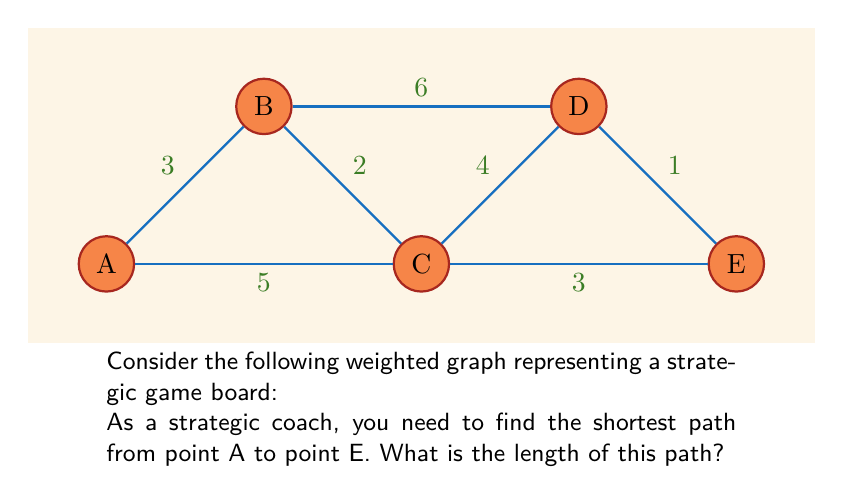Give your solution to this math problem. To solve this problem, we'll use Dijkstra's algorithm to find the shortest path from A to E. Let's go through the steps:

1) Initialize:
   - Distance to A: 0
   - Distance to all other nodes: $\infty$
   - Set of unvisited nodes: {A, B, C, D, E}

2) Start from node A:
   - Update distances:
     A to B: 3
     A to C: 5
   - Mark A as visited
   - Unvisited set: {B, C, D, E}

3) Choose the node with the smallest distance (B):
   - Update distances:
     B to C: min(5, 3+2) = 5
     B to D: 3+6 = 9
   - Mark B as visited
   - Unvisited set: {C, D, E}

4) Choose the node with the smallest distance (C):
   - Update distances:
     C to D: min(9, 5+4) = 9
     C to E: 5+3 = 8
   - Mark C as visited
   - Unvisited set: {D, E}

5) Choose the node with the smallest distance (E):
   - All nodes connecting to E are visited
   - Mark E as visited
   - Unvisited set: {D}

6) The algorithm terminates as we've reached E.

The shortest path from A to E is A -> C -> E, with a total length of 5 + 3 = 8.
Answer: 8 